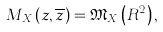<formula> <loc_0><loc_0><loc_500><loc_500>M _ { X } ( z , \overline { z } ) = \mathfrak { M } _ { X } \left ( R ^ { 2 } \right ) ,</formula> 